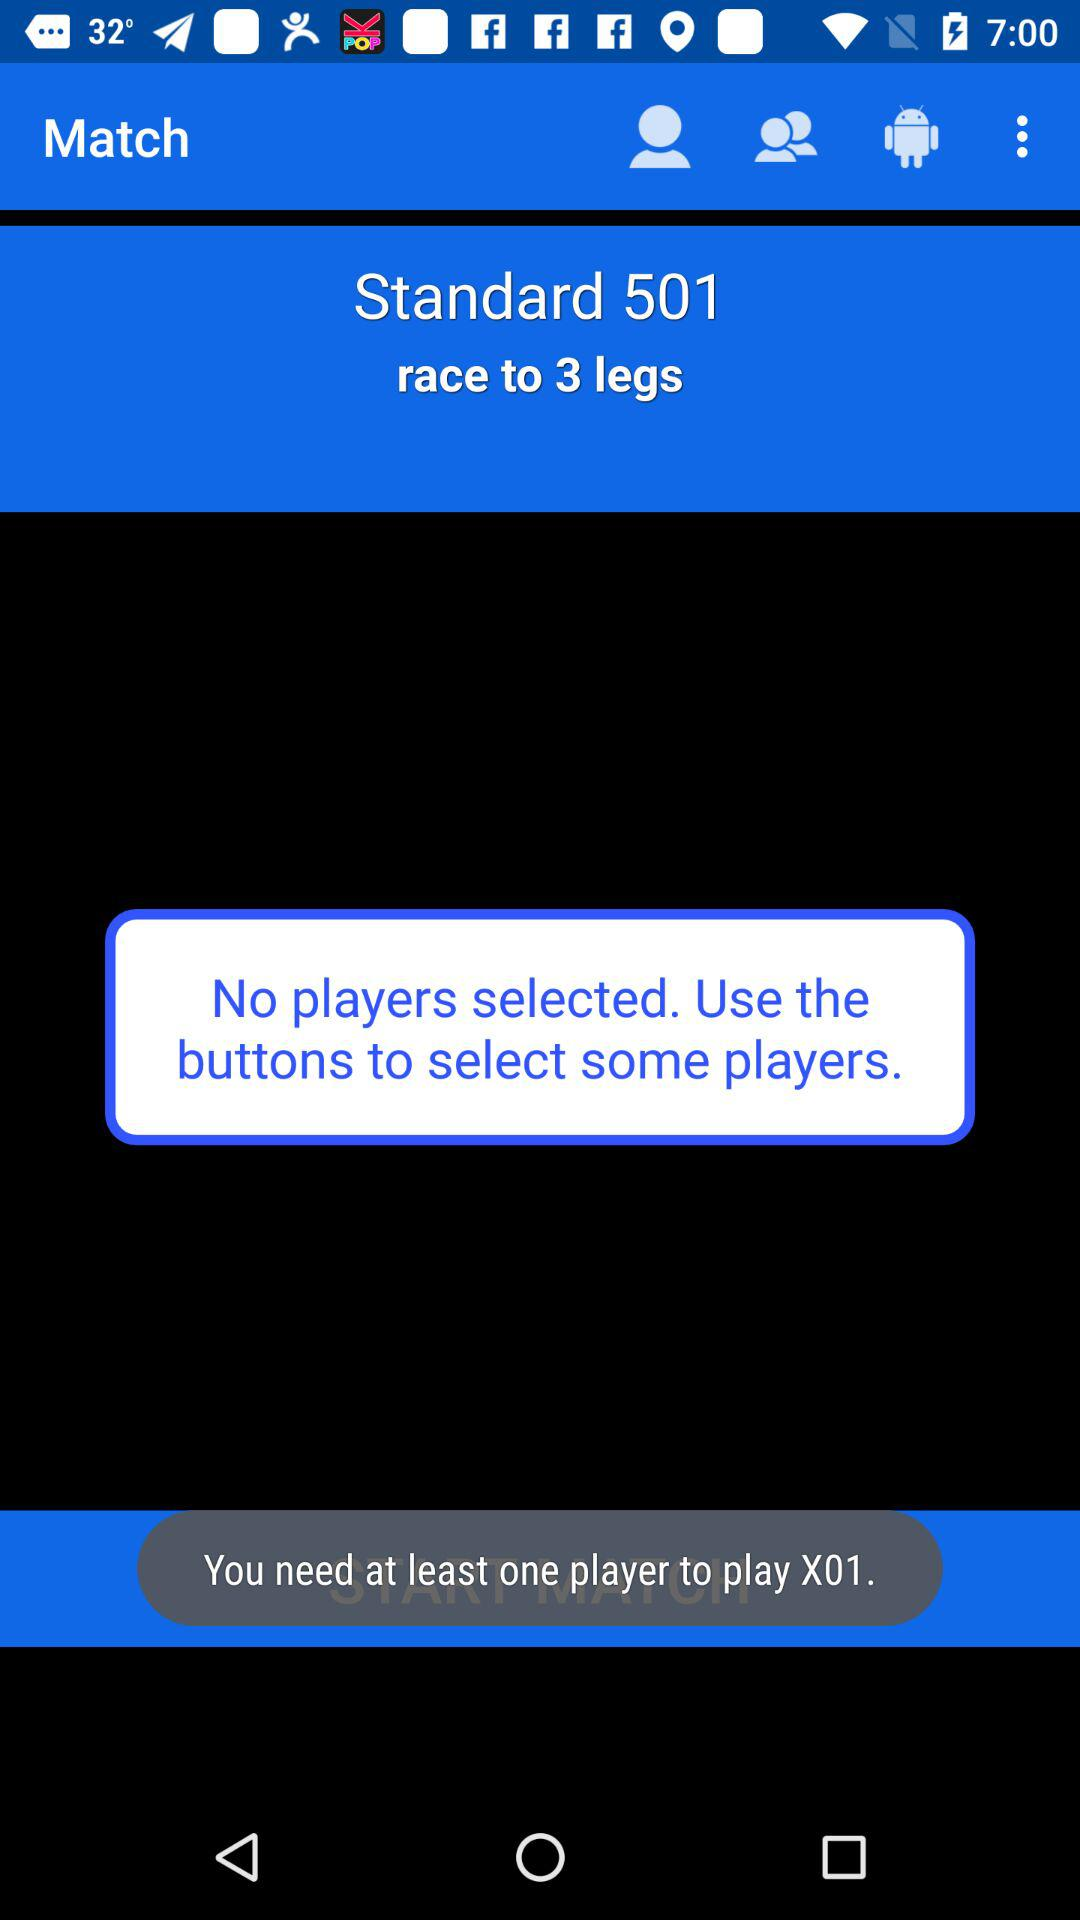How many more players do I need to select to play X01?
Answer the question using a single word or phrase. 1 